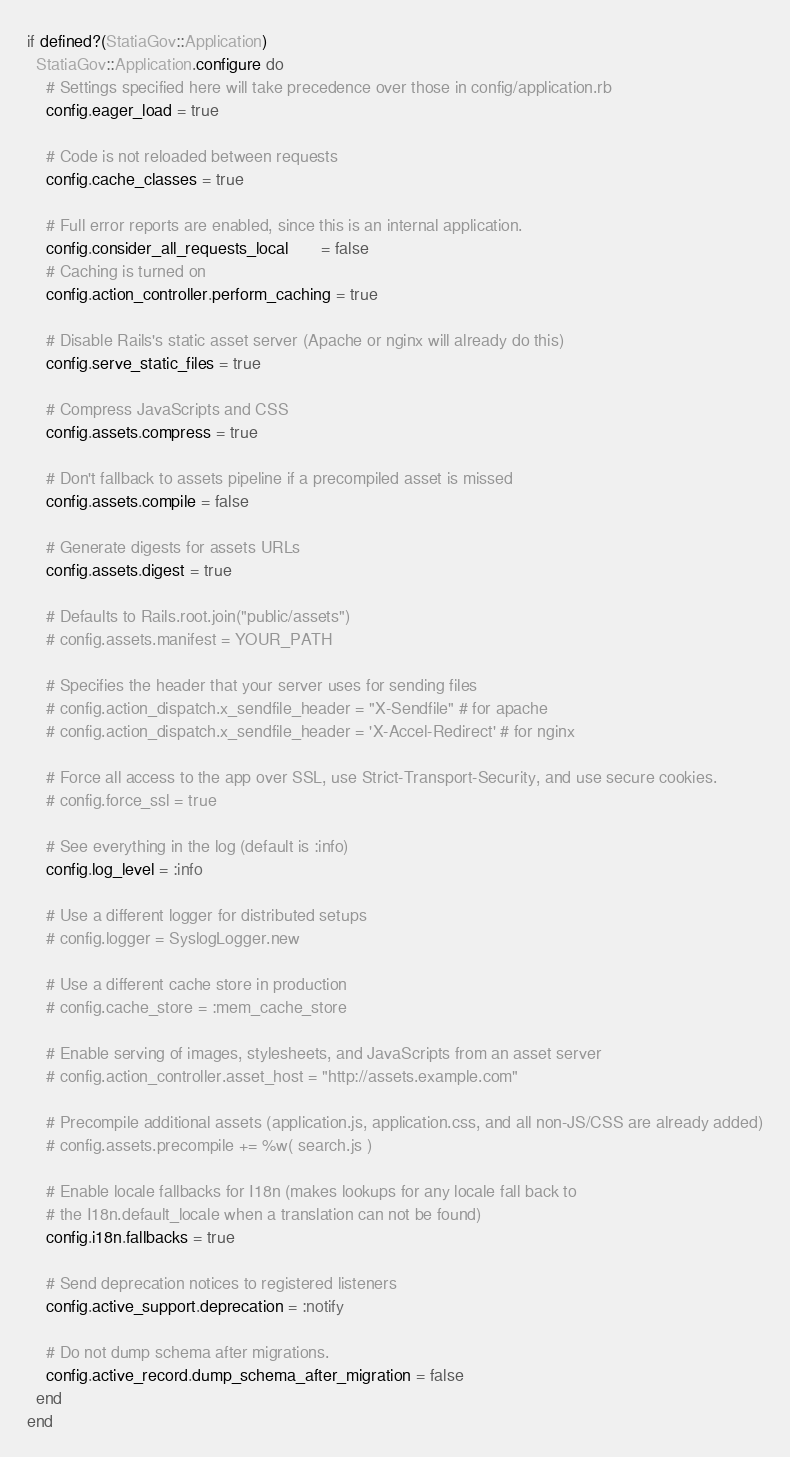<code> <loc_0><loc_0><loc_500><loc_500><_Ruby_>
if defined?(StatiaGov::Application)
  StatiaGov::Application.configure do
    # Settings specified here will take precedence over those in config/application.rb
    config.eager_load = true

    # Code is not reloaded between requests
    config.cache_classes = true

    # Full error reports are enabled, since this is an internal application.
    config.consider_all_requests_local       = false
    # Caching is turned on
    config.action_controller.perform_caching = true

    # Disable Rails's static asset server (Apache or nginx will already do this)
    config.serve_static_files = true

    # Compress JavaScripts and CSS
    config.assets.compress = true

    # Don't fallback to assets pipeline if a precompiled asset is missed
    config.assets.compile = false

    # Generate digests for assets URLs
    config.assets.digest = true

    # Defaults to Rails.root.join("public/assets")
    # config.assets.manifest = YOUR_PATH

    # Specifies the header that your server uses for sending files
    # config.action_dispatch.x_sendfile_header = "X-Sendfile" # for apache
    # config.action_dispatch.x_sendfile_header = 'X-Accel-Redirect' # for nginx

    # Force all access to the app over SSL, use Strict-Transport-Security, and use secure cookies.
    # config.force_ssl = true

    # See everything in the log (default is :info)
    config.log_level = :info

    # Use a different logger for distributed setups
    # config.logger = SyslogLogger.new

    # Use a different cache store in production
    # config.cache_store = :mem_cache_store

    # Enable serving of images, stylesheets, and JavaScripts from an asset server
    # config.action_controller.asset_host = "http://assets.example.com"

    # Precompile additional assets (application.js, application.css, and all non-JS/CSS are already added)
    # config.assets.precompile += %w( search.js )

    # Enable locale fallbacks for I18n (makes lookups for any locale fall back to
    # the I18n.default_locale when a translation can not be found)
    config.i18n.fallbacks = true

    # Send deprecation notices to registered listeners
    config.active_support.deprecation = :notify

    # Do not dump schema after migrations.
    config.active_record.dump_schema_after_migration = false
  end
end
</code> 